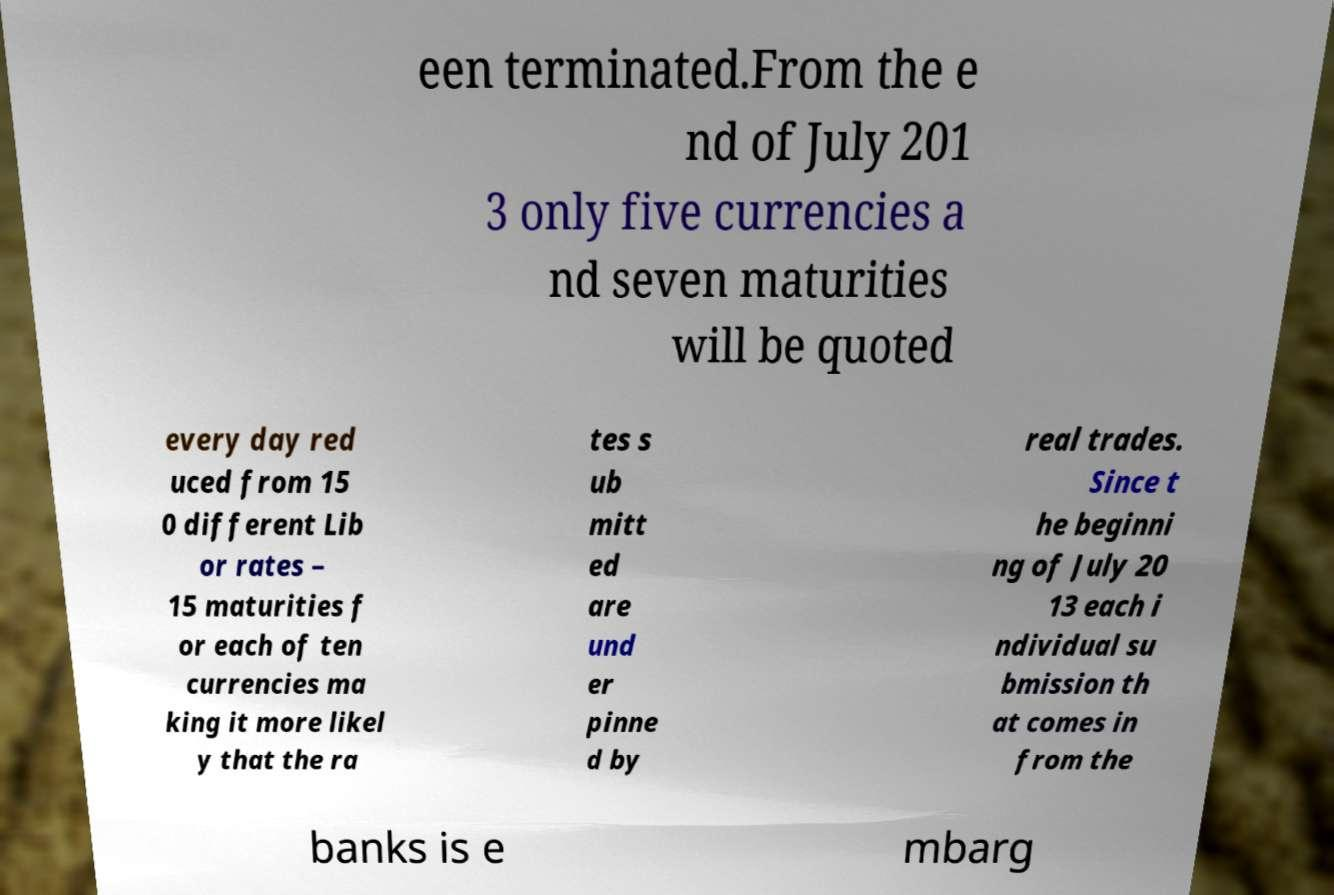For documentation purposes, I need the text within this image transcribed. Could you provide that? een terminated.From the e nd of July 201 3 only five currencies a nd seven maturities will be quoted every day red uced from 15 0 different Lib or rates – 15 maturities f or each of ten currencies ma king it more likel y that the ra tes s ub mitt ed are und er pinne d by real trades. Since t he beginni ng of July 20 13 each i ndividual su bmission th at comes in from the banks is e mbarg 